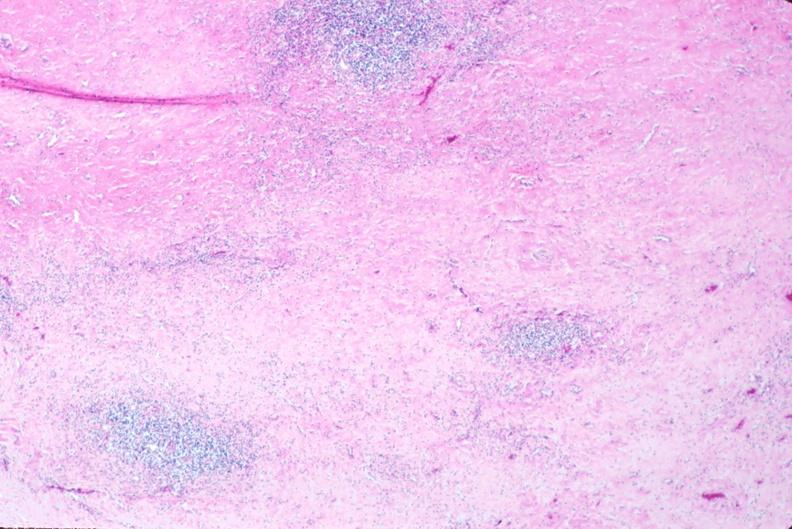does this image show lymph nodes, nodular sclerosing hodgkins disease?
Answer the question using a single word or phrase. Yes 